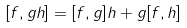<formula> <loc_0><loc_0><loc_500><loc_500>[ f , g h ] = [ f , g ] h + g [ f , h ]</formula> 